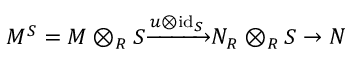Convert formula to latex. <formula><loc_0><loc_0><loc_500><loc_500>M ^ { S } = M \otimes _ { R } S { \xrightarrow { u \otimes { i d } _ { S } } } N _ { R } \otimes _ { R } S \to N</formula> 